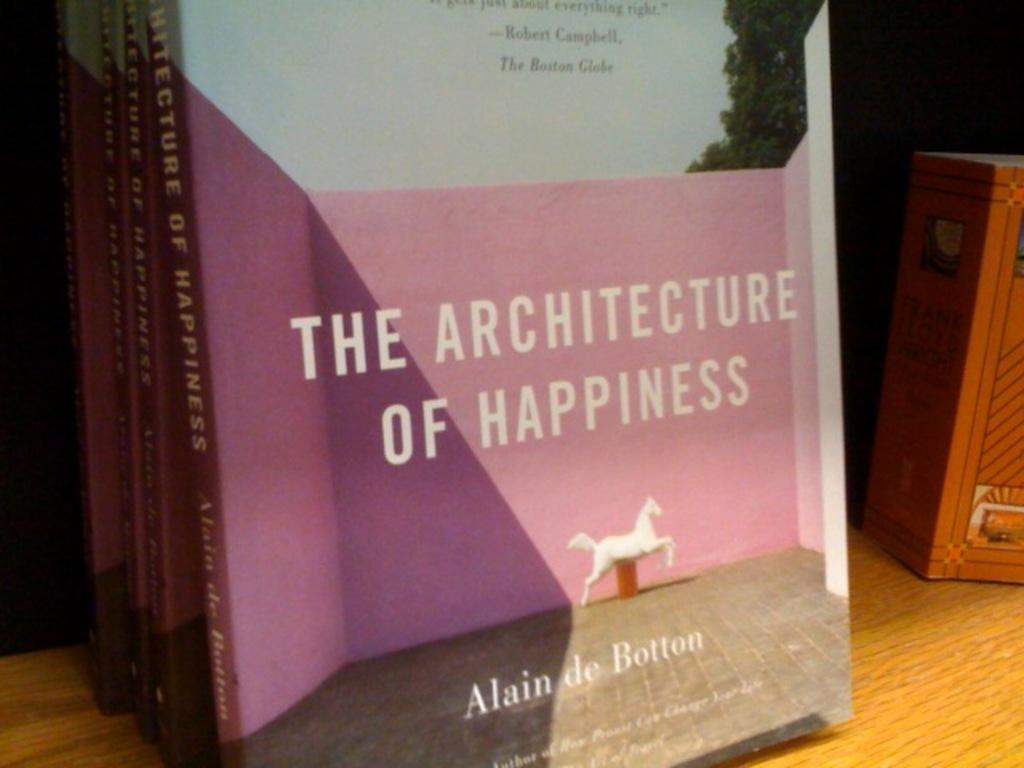<image>
Give a short and clear explanation of the subsequent image. The book is titled The Architecture of Happiness 